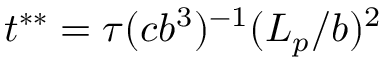<formula> <loc_0><loc_0><loc_500><loc_500>t ^ { * * } = \tau ( c b ^ { 3 } ) ^ { - 1 } ( L _ { p } / b ) ^ { 2 }</formula> 